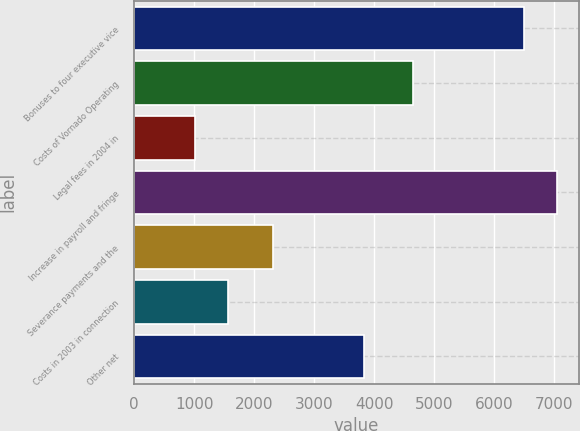Convert chart to OTSL. <chart><loc_0><loc_0><loc_500><loc_500><bar_chart><fcel>Bonuses to four executive vice<fcel>Costs of Vornado Operating<fcel>Legal fees in 2004 in<fcel>Increase in payroll and fringe<fcel>Severance payments and the<fcel>Costs in 2003 in connection<fcel>Other net<nl><fcel>6500<fcel>4643<fcel>1004<fcel>7055.1<fcel>2319<fcel>1559.1<fcel>3826<nl></chart> 